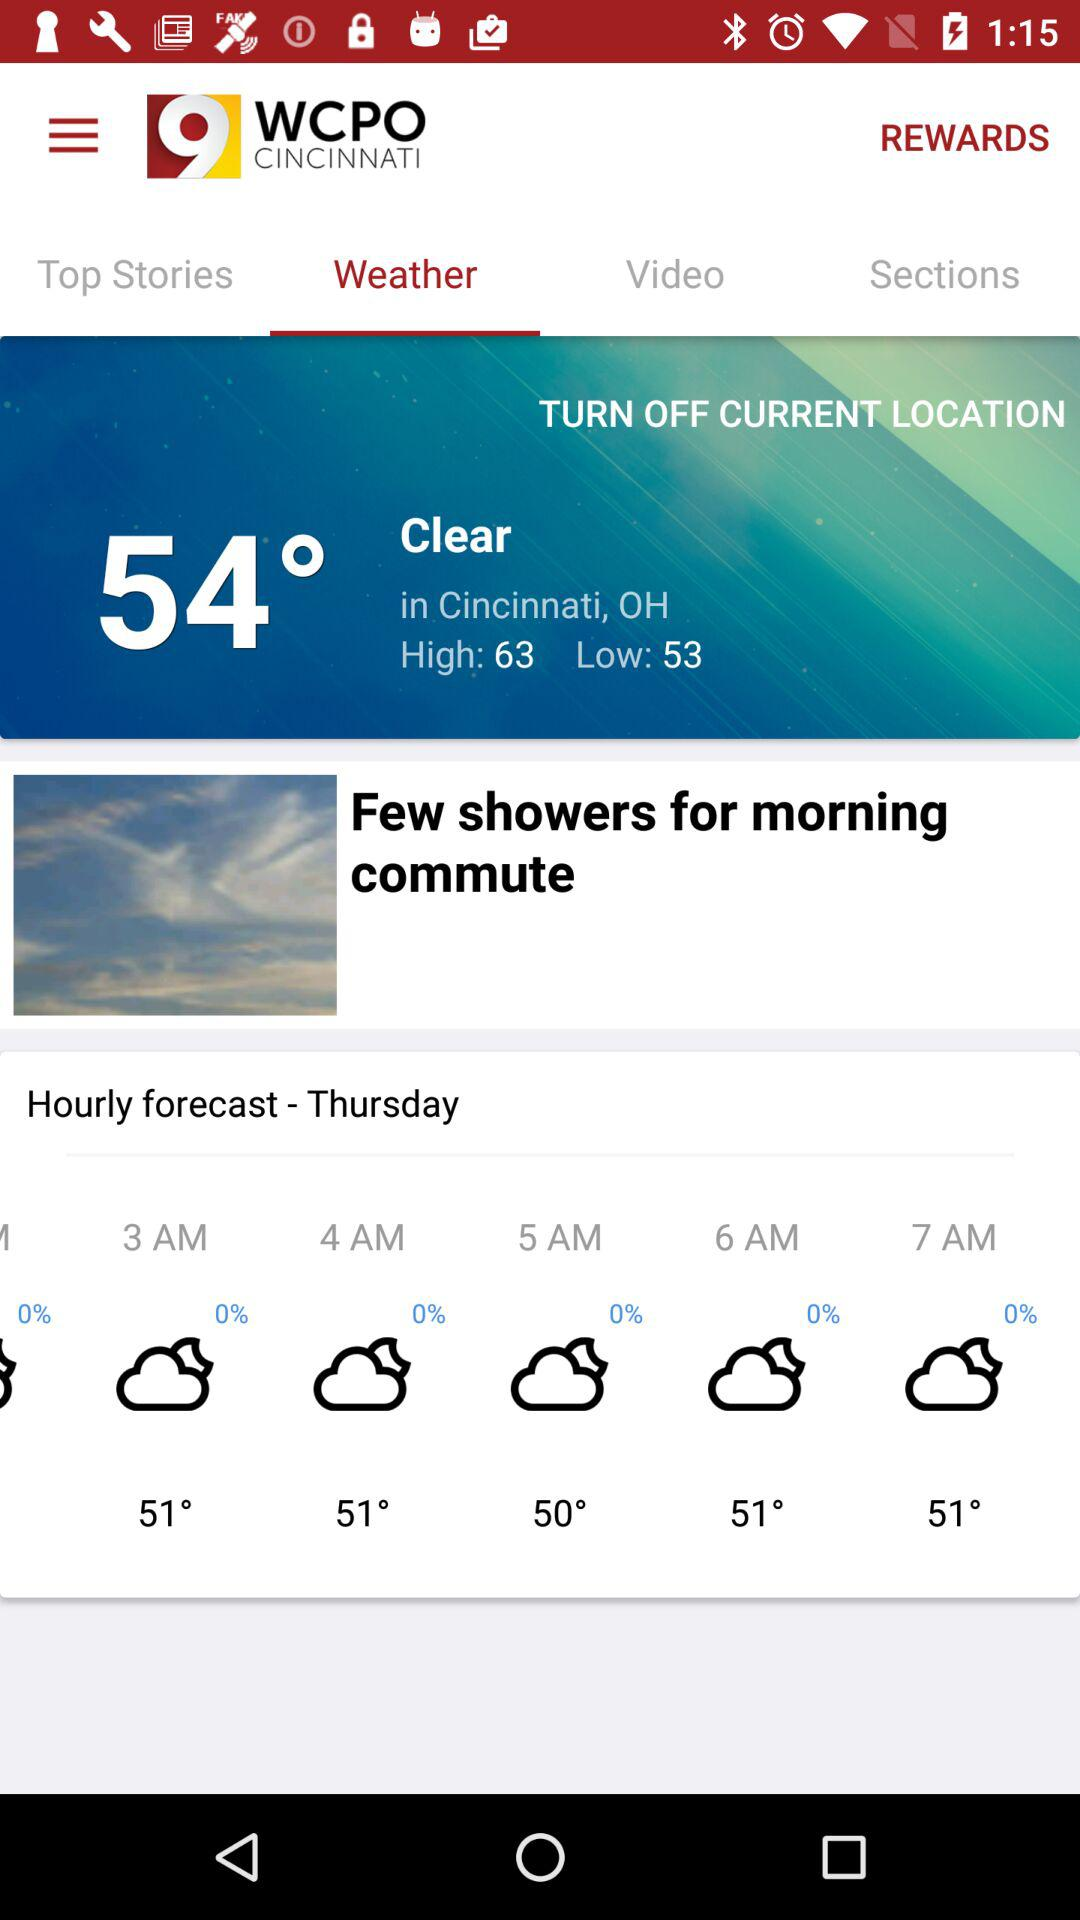Which day of the hourly forecast is given? The day is Thursday. 